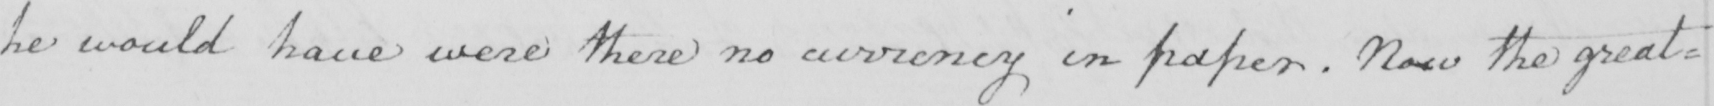Transcribe the text shown in this historical manuscript line. he would have were there no currency in paper . Now the great= 